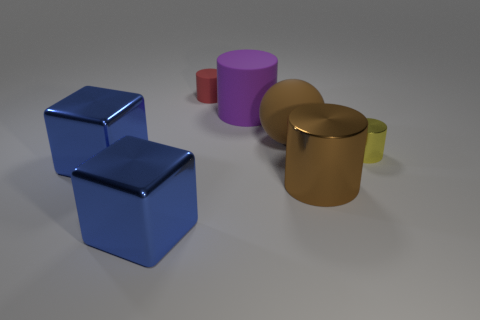How many things are either big green spheres or large purple rubber things?
Your answer should be very brief. 1. What number of blue cylinders are made of the same material as the red object?
Keep it short and to the point. 0. What size is the yellow shiny object that is the same shape as the large brown metal object?
Ensure brevity in your answer.  Small. Are there any brown rubber balls in front of the brown metal thing?
Your answer should be very brief. No. What material is the small yellow thing?
Keep it short and to the point. Metal. Do the cube that is in front of the large brown cylinder and the large ball have the same color?
Your response must be concise. No. Are there any other things that are the same shape as the purple object?
Give a very brief answer. Yes. There is another small object that is the same shape as the small red object; what is its color?
Keep it short and to the point. Yellow. There is a large thing that is on the right side of the brown matte ball; what is its material?
Offer a terse response. Metal. What is the color of the large matte ball?
Offer a terse response. Brown. 